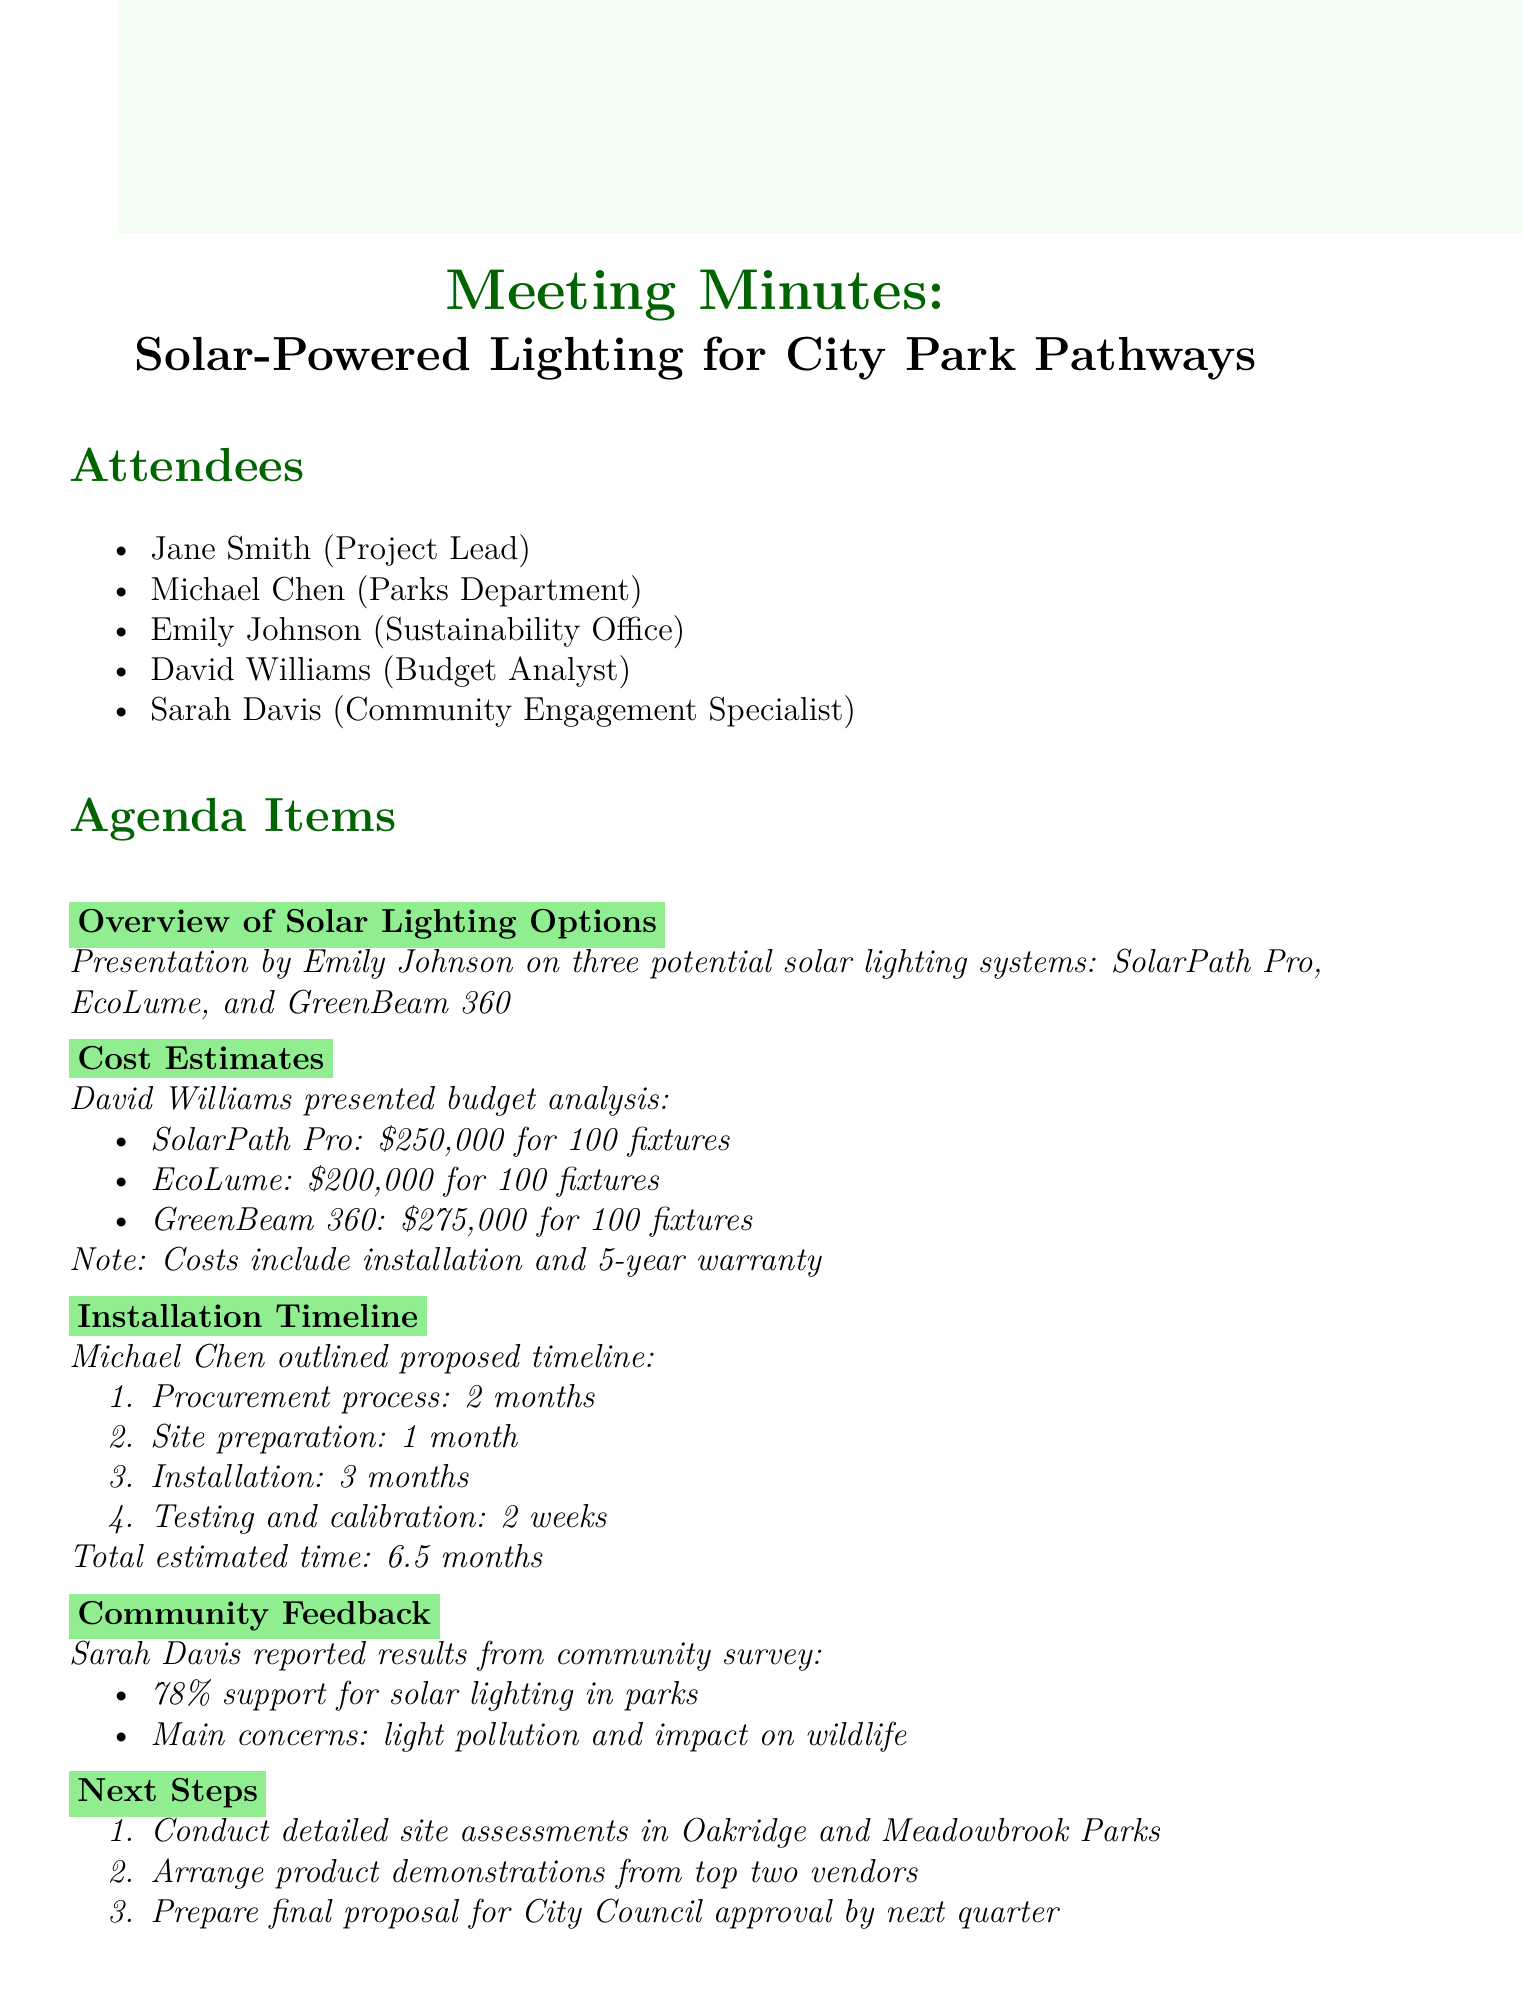What are the three solar lighting systems presented? The document lists three solar lighting systems presented by Emily Johnson, which are SolarPath Pro, EcoLume, and GreenBeam 360.
Answer: SolarPath Pro, EcoLume, GreenBeam 360 What is the cost of EcoLume for 100 fixtures? The document states that the cost for EcoLume is $200,000 for 100 fixtures.
Answer: $200,000 How long is the procurement process estimated to take? According to the document, the procurement process is estimated to take 2 months.
Answer: 2 months What percentage of community members support solar lighting in parks? The document mentions that 78% of community members support solar lighting in parks.
Answer: 78% What is the total estimated time for installation and testing? The document outlines a total estimated time of 6.5 months for the entire installation and testing process.
Answer: 6.5 months Which two parks are mentioned for site assessments? The document lists Oakridge and Meadowbrook Parks for conducting detailed site assessments.
Answer: Oakridge and Meadowbrook Parks How many fixtures are included in the cost estimates? The document specifies that 100 fixtures are included in all the cost estimates presented.
Answer: 100 fixtures What are the main concerns reported from the community survey? The document indicates that the main concerns from the community survey are light pollution and impact on wildlife.
Answer: Light pollution and impact on wildlife 